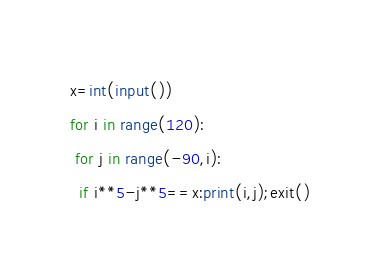Convert code to text. <code><loc_0><loc_0><loc_500><loc_500><_Python_>x=int(input())
for i in range(120):
 for j in range(-90,i):
  if i**5-j**5==x:print(i,j);exit()</code> 